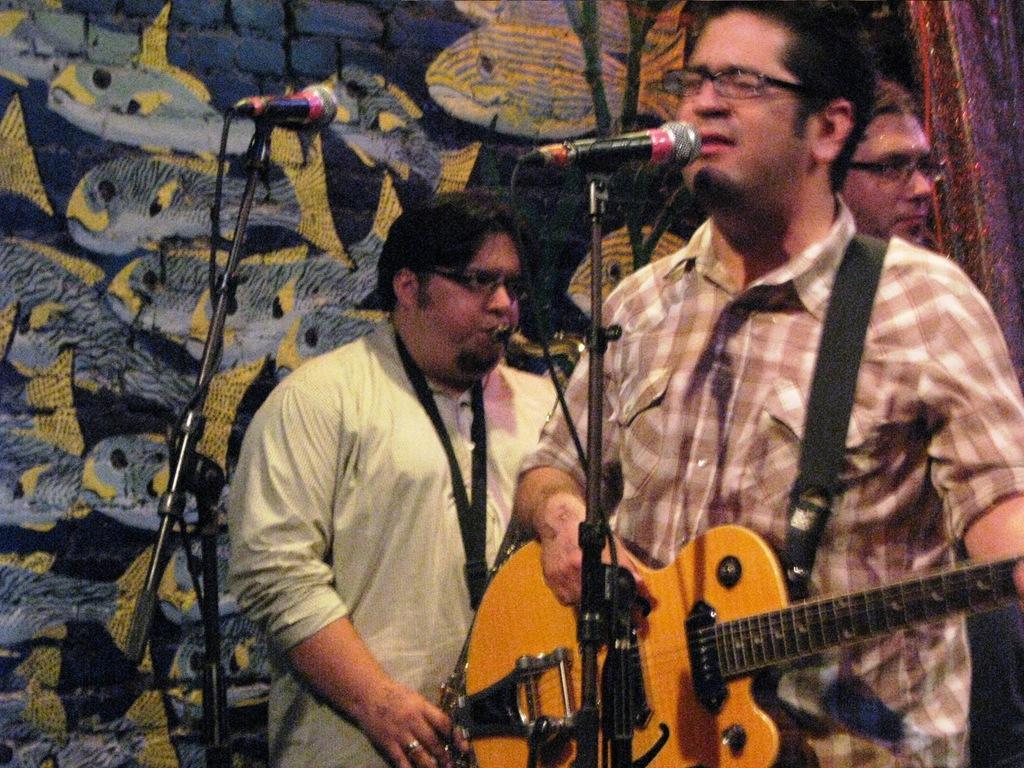Could you give a brief overview of what you see in this image? In the image we can see there are people who are standing and a man is holding guitar in his hand and behind there another man is playing a musical instrument and in front of him there is mic with a stand and at the back on the wall there are fishes painted. 